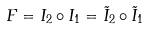<formula> <loc_0><loc_0><loc_500><loc_500>F = I _ { 2 } \circ I _ { 1 } = \tilde { I } _ { 2 } \circ \tilde { I } _ { 1 }</formula> 